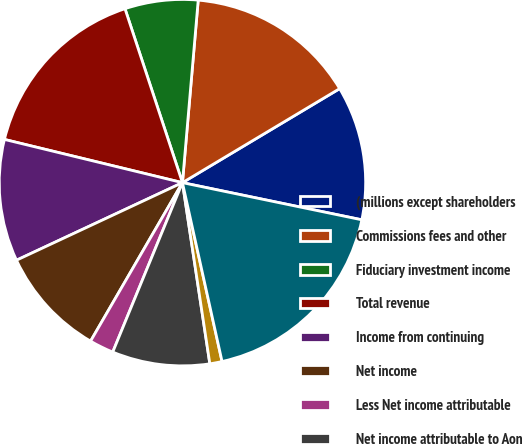Convert chart to OTSL. <chart><loc_0><loc_0><loc_500><loc_500><pie_chart><fcel>(millions except shareholders<fcel>Commissions fees and other<fcel>Fiduciary investment income<fcel>Total revenue<fcel>Income from continuing<fcel>Net income<fcel>Less Net income attributable<fcel>Net income attributable to Aon<fcel>Continuing operations<fcel>Fiduciary assets (3)<nl><fcel>11.83%<fcel>15.05%<fcel>6.45%<fcel>16.13%<fcel>10.75%<fcel>9.68%<fcel>2.15%<fcel>8.6%<fcel>1.08%<fcel>18.28%<nl></chart> 